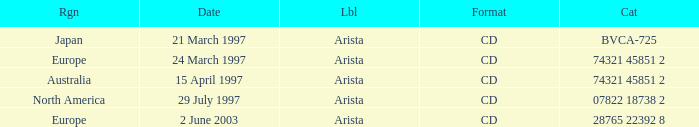What's the Date with the Region of Europe and has a Catalog of 28765 22392 8? 2 June 2003. 